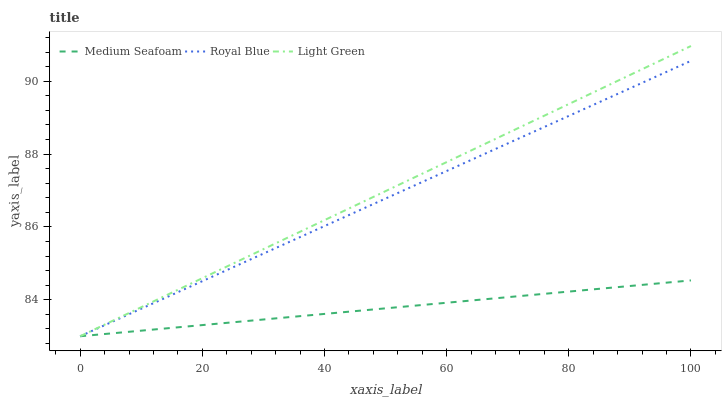Does Light Green have the minimum area under the curve?
Answer yes or no. No. Does Medium Seafoam have the maximum area under the curve?
Answer yes or no. No. Is Light Green the smoothest?
Answer yes or no. No. Is Light Green the roughest?
Answer yes or no. No. Does Medium Seafoam have the highest value?
Answer yes or no. No. 